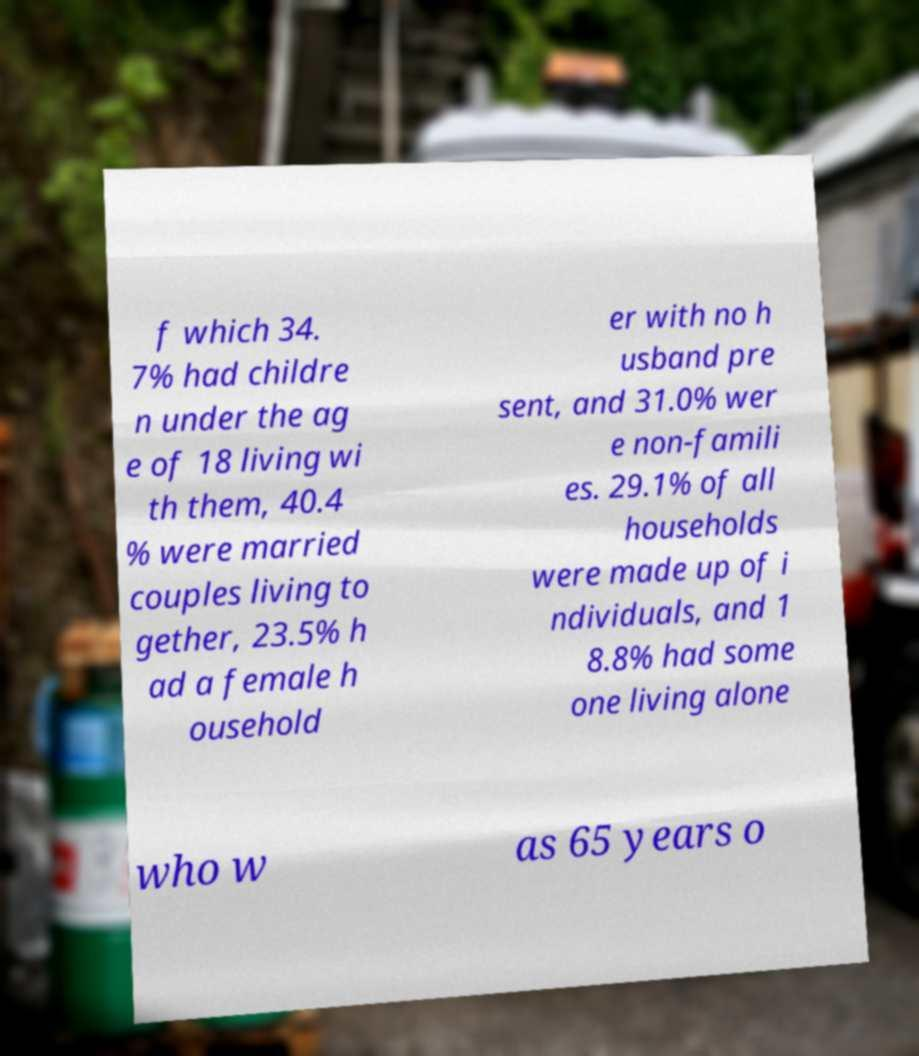Could you extract and type out the text from this image? f which 34. 7% had childre n under the ag e of 18 living wi th them, 40.4 % were married couples living to gether, 23.5% h ad a female h ousehold er with no h usband pre sent, and 31.0% wer e non-famili es. 29.1% of all households were made up of i ndividuals, and 1 8.8% had some one living alone who w as 65 years o 